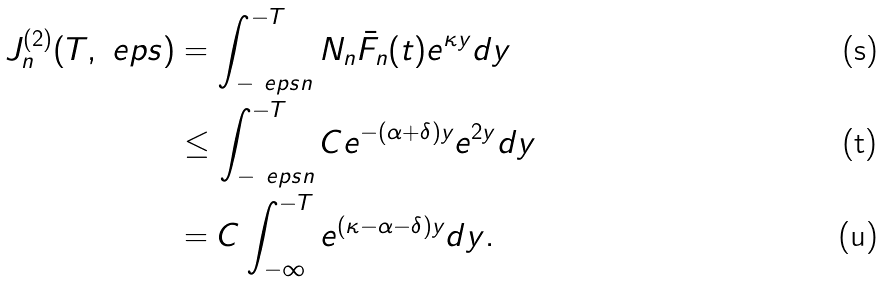Convert formula to latex. <formula><loc_0><loc_0><loc_500><loc_500>J _ { n } ^ { ( 2 ) } ( T , \ e p s ) & = \int _ { - \ e p s n } ^ { - T } N _ { n } \bar { F } _ { n } ( t ) e ^ { \kappa y } d y \\ & \leq \int _ { - \ e p s n } ^ { - T } C e ^ { - ( \alpha + \delta ) y } e ^ { 2 y } d y \\ & = C \int _ { - \infty } ^ { - T } e ^ { ( \kappa - \alpha - \delta ) y } d y .</formula> 